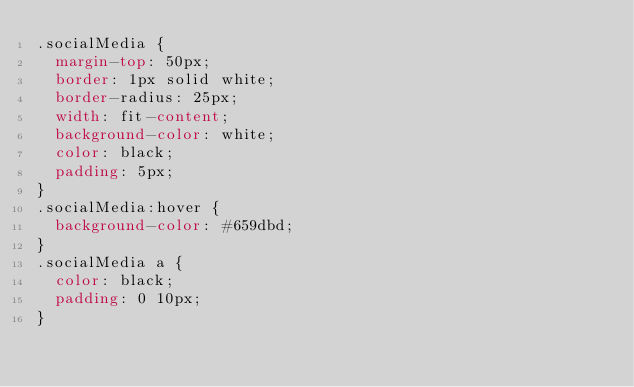Convert code to text. <code><loc_0><loc_0><loc_500><loc_500><_CSS_>.socialMedia {
  margin-top: 50px;
  border: 1px solid white;
  border-radius: 25px;
  width: fit-content;
  background-color: white;
  color: black;
  padding: 5px;
}
.socialMedia:hover {
  background-color: #659dbd;
}
.socialMedia a {
  color: black;
  padding: 0 10px;
}
</code> 